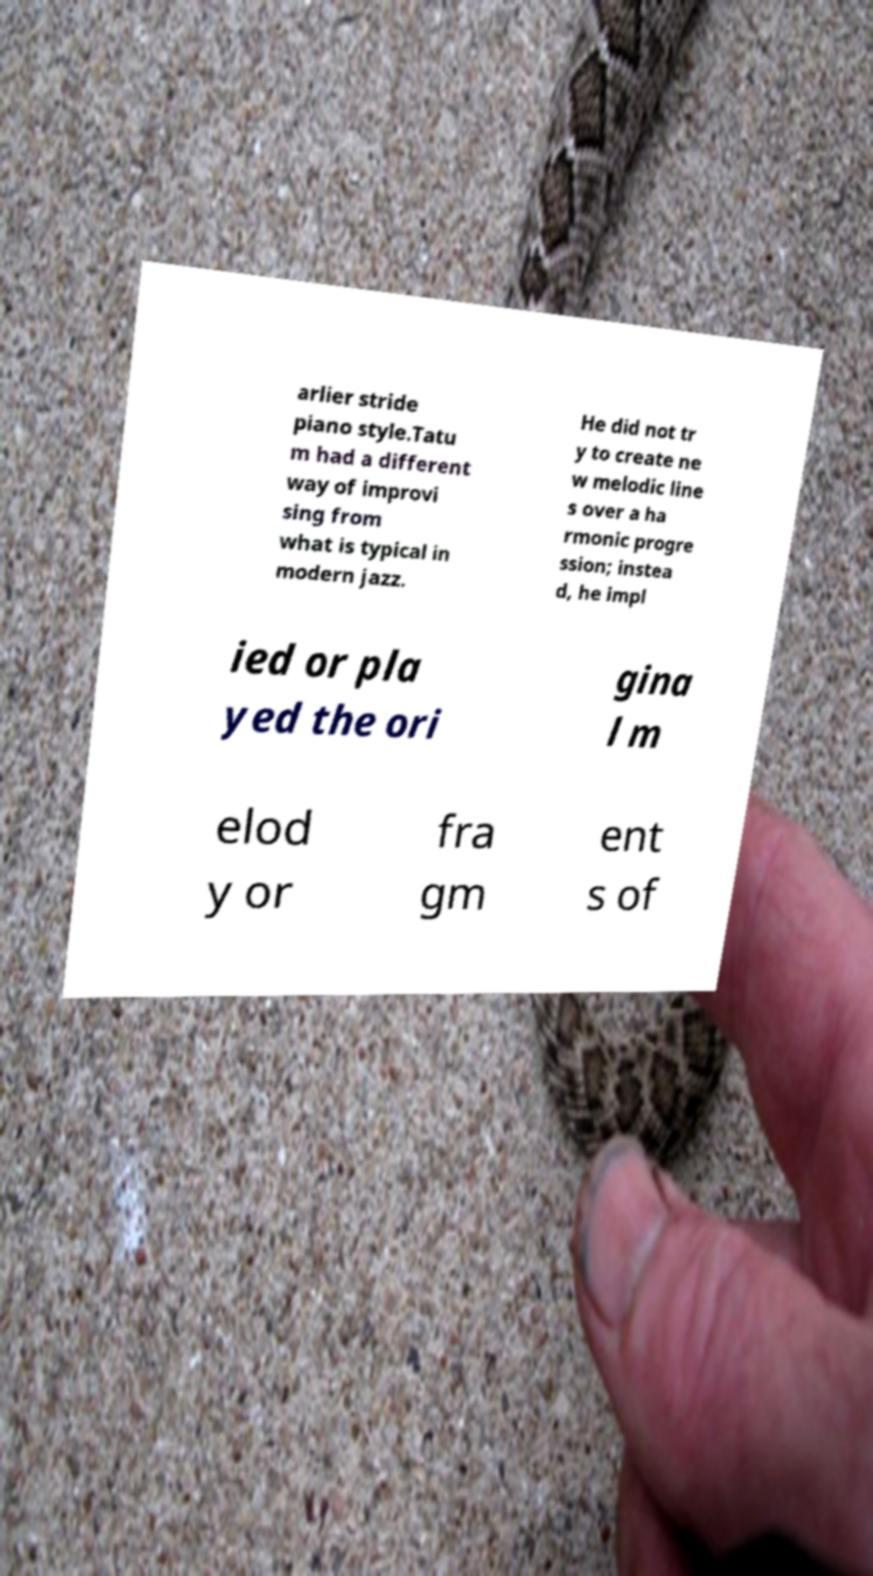Can you read and provide the text displayed in the image?This photo seems to have some interesting text. Can you extract and type it out for me? arlier stride piano style.Tatu m had a different way of improvi sing from what is typical in modern jazz. He did not tr y to create ne w melodic line s over a ha rmonic progre ssion; instea d, he impl ied or pla yed the ori gina l m elod y or fra gm ent s of 